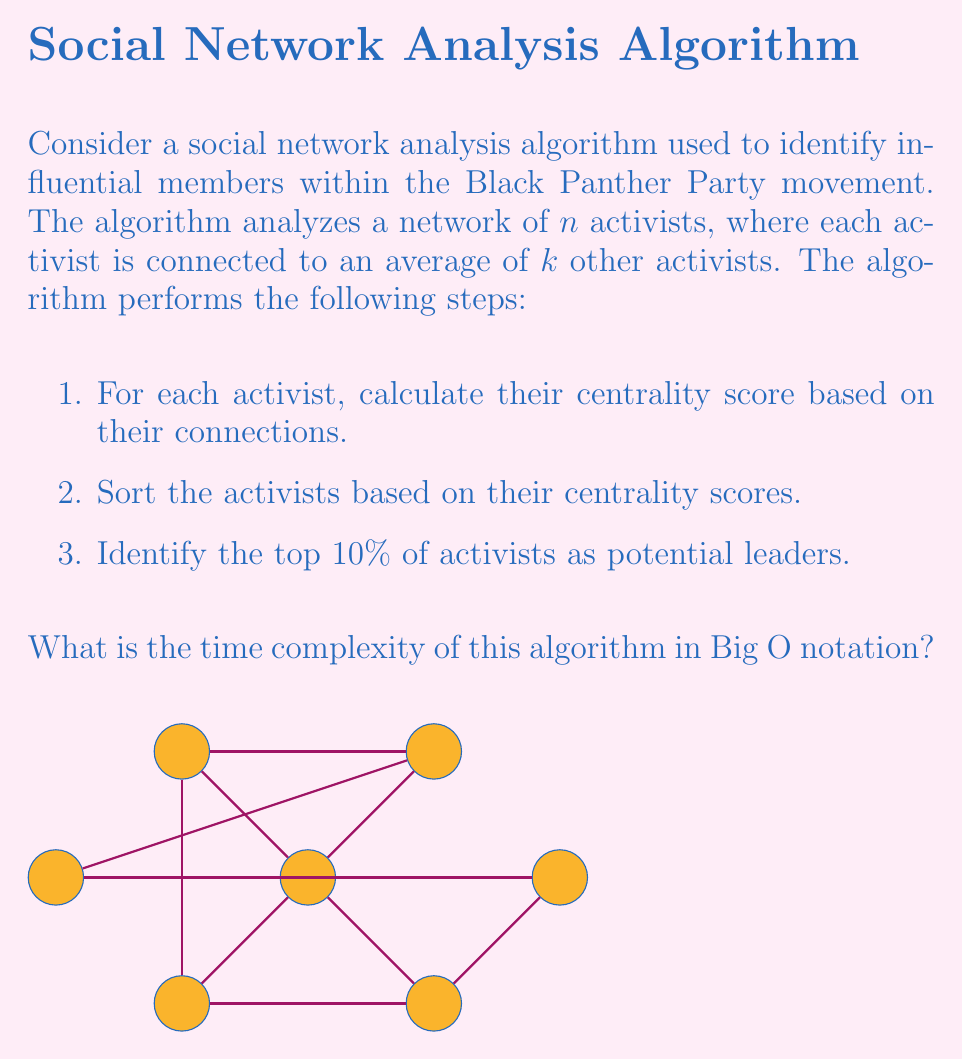Can you solve this math problem? Let's analyze the time complexity of each step:

1. Calculating centrality scores:
   - For each activist (n iterations), we examine their connections (k iterations on average).
   - Time complexity: $O(n \cdot k)$

2. Sorting activists based on centrality scores:
   - Using an efficient sorting algorithm like Merge Sort or Quick Sort.
   - Time complexity: $O(n \log n)$

3. Identifying top 10% of activists:
   - This is a simple selection of a fixed percentage of the sorted list.
   - Time complexity: $O(n)$

The overall time complexity is the sum of these steps:

$$O(n \cdot k) + O(n \log n) + O(n)$$

To simplify this, we need to consider the dominant term. In most real-world social networks, $k$ (the average number of connections) is much smaller than $n$ (the total number of activists) and can be considered constant. Therefore:

$$O(n \cdot k) \approx O(n)$$

Now our simplified time complexity is:

$$O(n) + O(n \log n) + O(n)$$

The dominant term here is $O(n \log n)$, which comes from the sorting step.

Therefore, the overall time complexity of the algorithm is $O(n \log n)$.
Answer: $O(n \log n)$ 